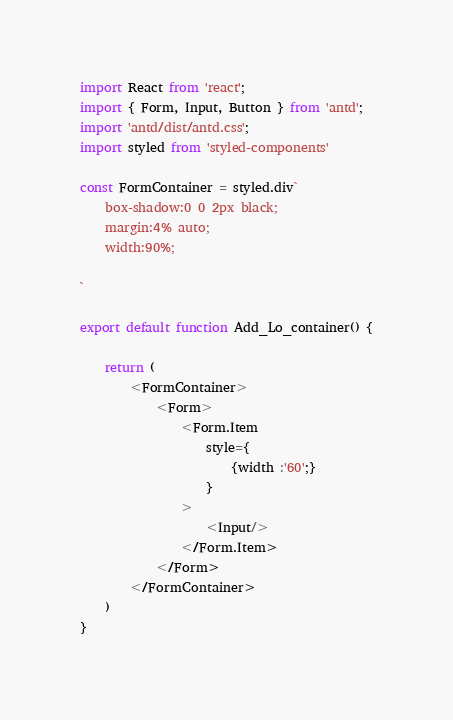<code> <loc_0><loc_0><loc_500><loc_500><_JavaScript_>import React from 'react';
import { Form, Input, Button } from 'antd';
import 'antd/dist/antd.css';
import styled from 'styled-components'

const FormContainer = styled.div`
    box-shadow:0 0 2px black;
    margin:4% auto;
    width:90%;

`

export default function Add_Lo_container() {
    
    return (
        <FormContainer>
            <Form>
                <Form.Item
                    style={
                        {width :'60';}
                    }
                >
                    <Input/>
                </Form.Item>
            </Form>
        </FormContainer>
    )
}
</code> 